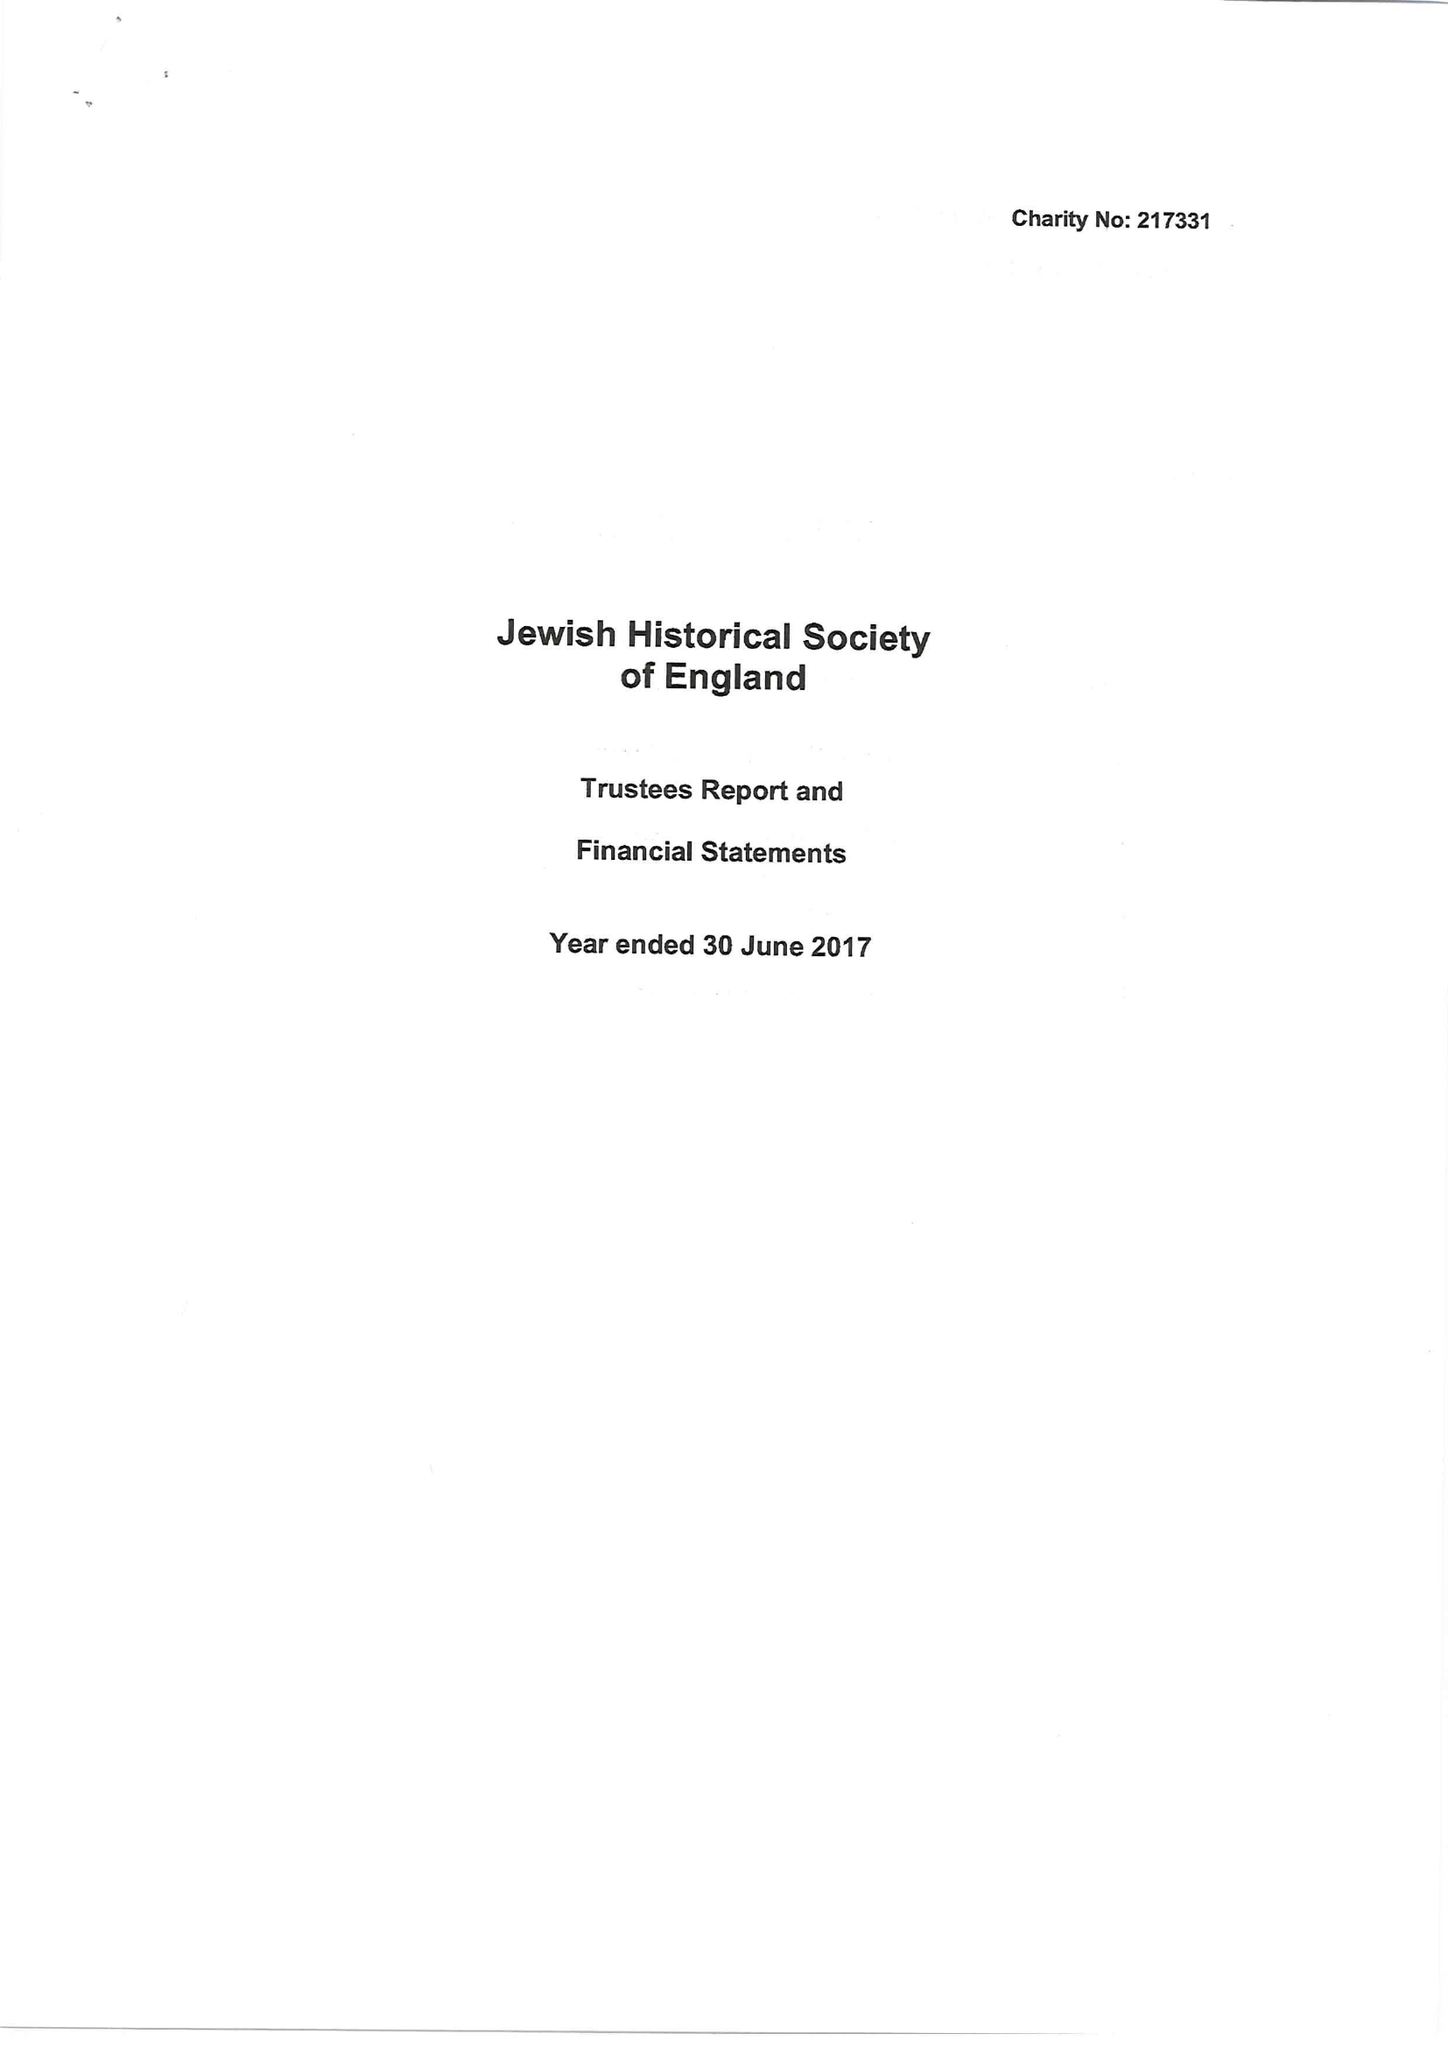What is the value for the address__post_town?
Answer the question using a single word or phrase. KING'S LYNN 